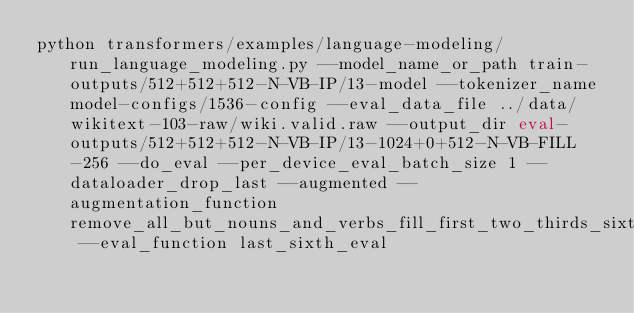<code> <loc_0><loc_0><loc_500><loc_500><_Bash_>python transformers/examples/language-modeling/run_language_modeling.py --model_name_or_path train-outputs/512+512+512-N-VB-IP/13-model --tokenizer_name model-configs/1536-config --eval_data_file ../data/wikitext-103-raw/wiki.valid.raw --output_dir eval-outputs/512+512+512-N-VB-IP/13-1024+0+512-N-VB-FILL-256 --do_eval --per_device_eval_batch_size 1 --dataloader_drop_last --augmented --augmentation_function remove_all_but_nouns_and_verbs_fill_first_two_thirds_sixth --eval_function last_sixth_eval</code> 